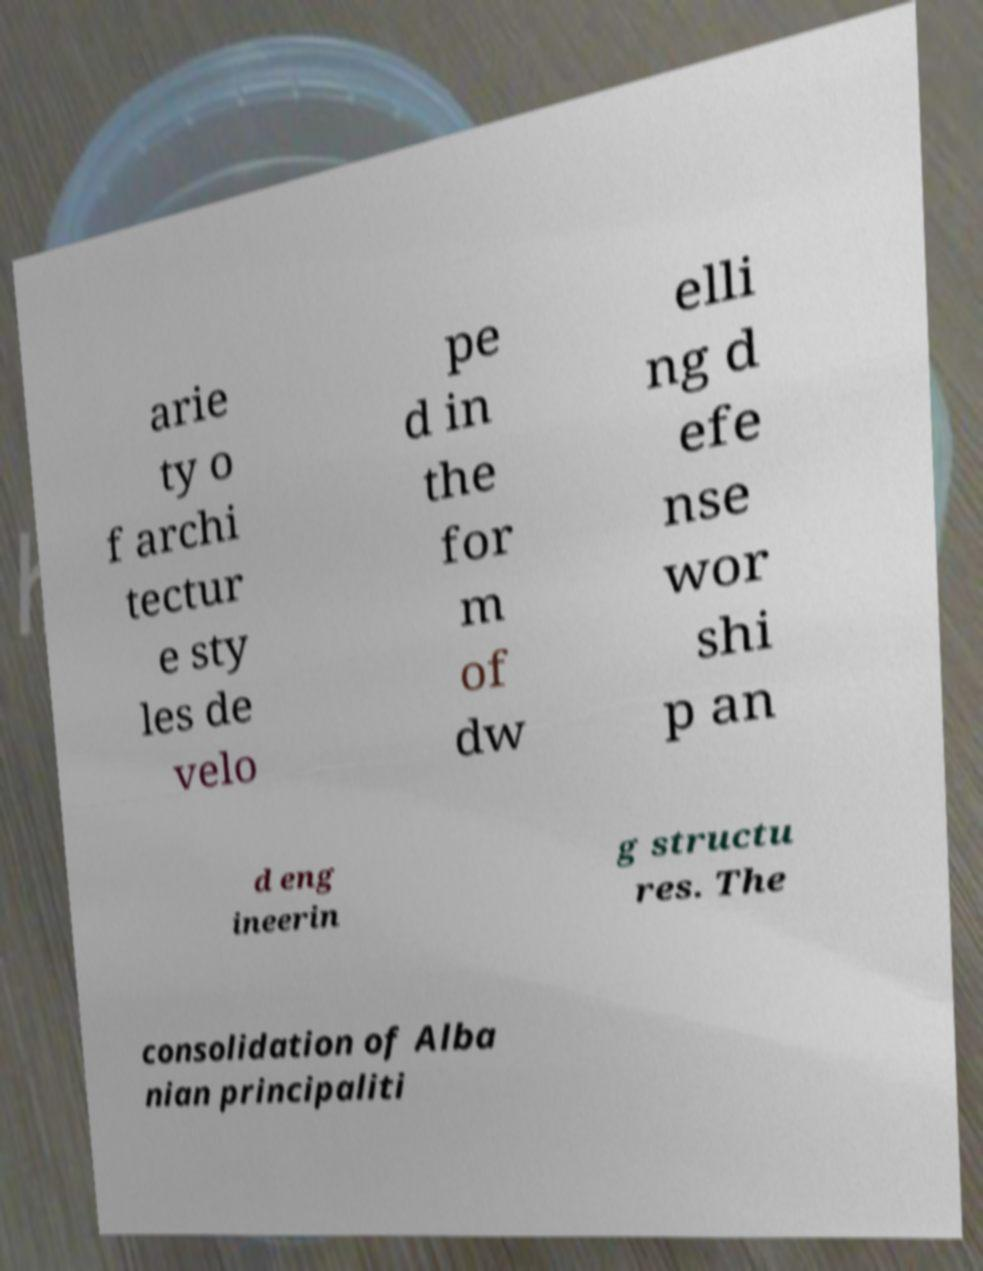What messages or text are displayed in this image? I need them in a readable, typed format. arie ty o f archi tectur e sty les de velo pe d in the for m of dw elli ng d efe nse wor shi p an d eng ineerin g structu res. The consolidation of Alba nian principaliti 